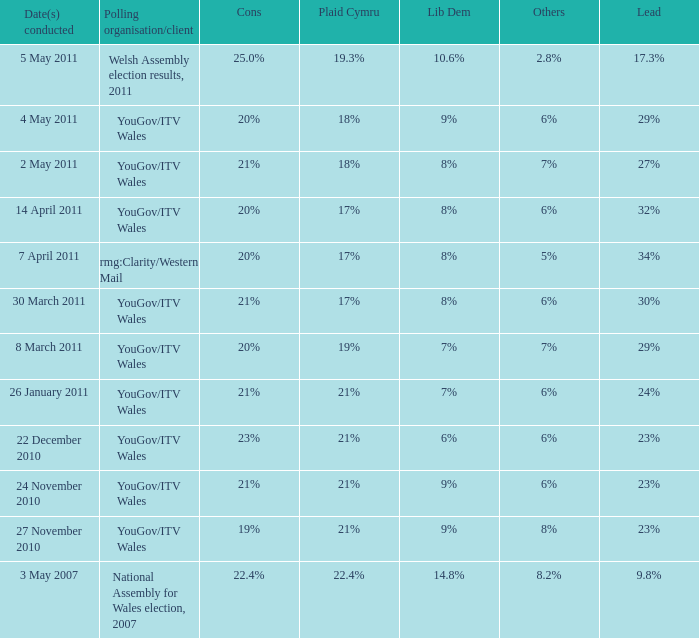Identify the downsides of possessing 21% cons and a 24% lead. 6%. Give me the full table as a dictionary. {'header': ['Date(s) conducted', 'Polling organisation/client', 'Cons', 'Plaid Cymru', 'Lib Dem', 'Others', 'Lead'], 'rows': [['5 May 2011', 'Welsh Assembly election results, 2011', '25.0%', '19.3%', '10.6%', '2.8%', '17.3%'], ['4 May 2011', 'YouGov/ITV Wales', '20%', '18%', '9%', '6%', '29%'], ['2 May 2011', 'YouGov/ITV Wales', '21%', '18%', '8%', '7%', '27%'], ['14 April 2011', 'YouGov/ITV Wales', '20%', '17%', '8%', '6%', '32%'], ['7 April 2011', 'rmg:Clarity/Western Mail', '20%', '17%', '8%', '5%', '34%'], ['30 March 2011', 'YouGov/ITV Wales', '21%', '17%', '8%', '6%', '30%'], ['8 March 2011', 'YouGov/ITV Wales', '20%', '19%', '7%', '7%', '29%'], ['26 January 2011', 'YouGov/ITV Wales', '21%', '21%', '7%', '6%', '24%'], ['22 December 2010', 'YouGov/ITV Wales', '23%', '21%', '6%', '6%', '23%'], ['24 November 2010', 'YouGov/ITV Wales', '21%', '21%', '9%', '6%', '23%'], ['27 November 2010', 'YouGov/ITV Wales', '19%', '21%', '9%', '8%', '23%'], ['3 May 2007', 'National Assembly for Wales election, 2007', '22.4%', '22.4%', '14.8%', '8.2%', '9.8%']]} 